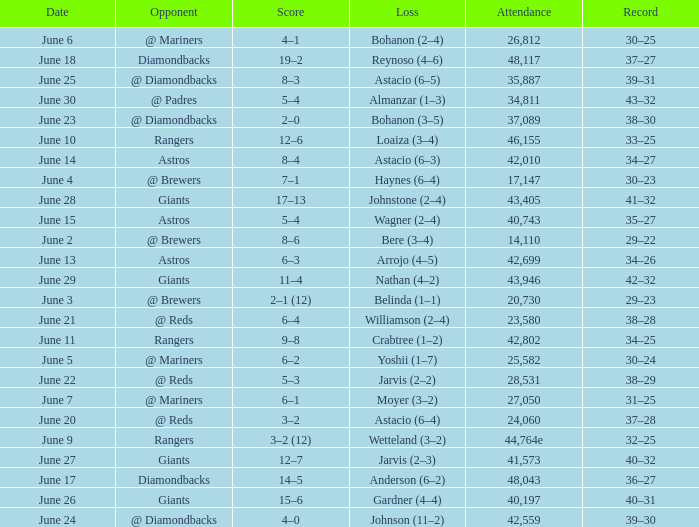Who's the opponent for June 13? Astros. 